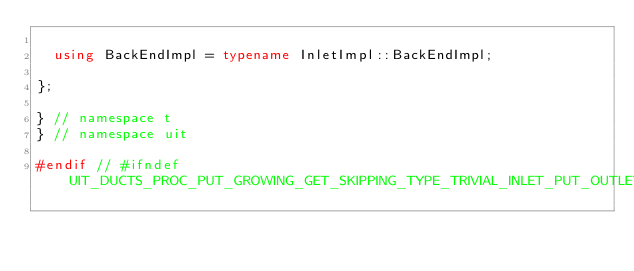Convert code to text. <code><loc_0><loc_0><loc_500><loc_500><_C++_>
  using BackEndImpl = typename InletImpl::BackEndImpl;

};

} // namespace t
} // namespace uit

#endif // #ifndef UIT_DUCTS_PROC_PUT_GROWING_GET_SKIPPING_TYPE_TRIVIAL_INLET_PUT_OUTLET_WINDOW_T__IPOWDUCT_HPP_INCLUDE
</code> 